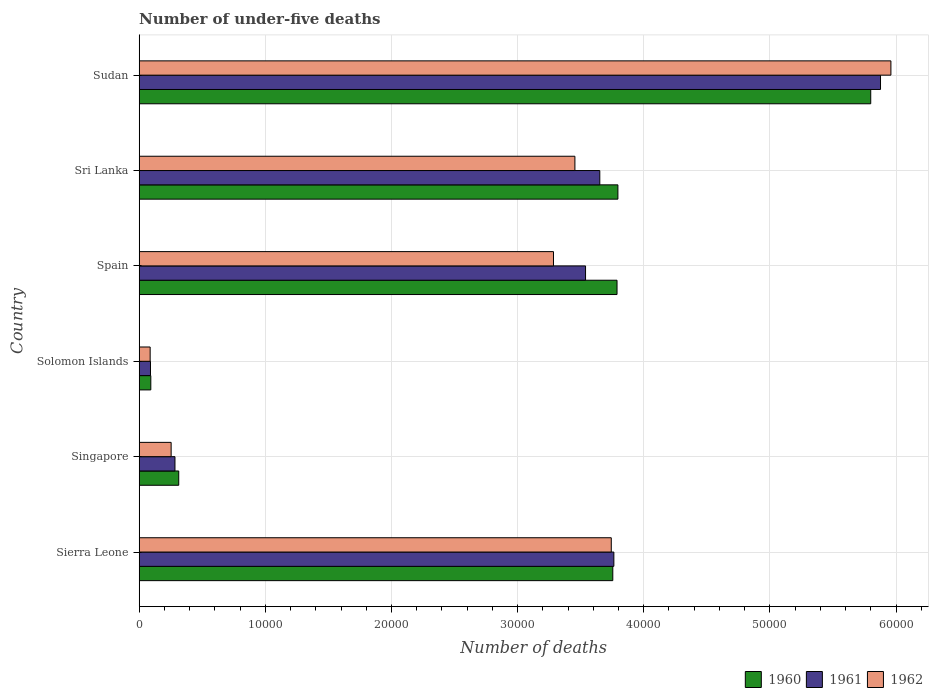How many different coloured bars are there?
Offer a very short reply. 3. How many groups of bars are there?
Keep it short and to the point. 6. Are the number of bars per tick equal to the number of legend labels?
Provide a succinct answer. Yes. How many bars are there on the 2nd tick from the top?
Provide a succinct answer. 3. What is the label of the 6th group of bars from the top?
Make the answer very short. Sierra Leone. What is the number of under-five deaths in 1960 in Sudan?
Provide a short and direct response. 5.80e+04. Across all countries, what is the maximum number of under-five deaths in 1961?
Offer a terse response. 5.88e+04. Across all countries, what is the minimum number of under-five deaths in 1962?
Ensure brevity in your answer.  872. In which country was the number of under-five deaths in 1961 maximum?
Offer a terse response. Sudan. In which country was the number of under-five deaths in 1961 minimum?
Make the answer very short. Solomon Islands. What is the total number of under-five deaths in 1960 in the graph?
Give a very brief answer. 1.75e+05. What is the difference between the number of under-five deaths in 1961 in Spain and that in Sri Lanka?
Your answer should be compact. -1130. What is the difference between the number of under-five deaths in 1962 in Sierra Leone and the number of under-five deaths in 1960 in Spain?
Give a very brief answer. -456. What is the average number of under-five deaths in 1961 per country?
Offer a terse response. 2.87e+04. What is the difference between the number of under-five deaths in 1962 and number of under-five deaths in 1961 in Singapore?
Offer a terse response. -304. In how many countries, is the number of under-five deaths in 1960 greater than 18000 ?
Your response must be concise. 4. What is the ratio of the number of under-five deaths in 1961 in Sierra Leone to that in Solomon Islands?
Offer a terse response. 41.95. Is the number of under-five deaths in 1961 in Singapore less than that in Sri Lanka?
Provide a succinct answer. Yes. Is the difference between the number of under-five deaths in 1962 in Spain and Sri Lanka greater than the difference between the number of under-five deaths in 1961 in Spain and Sri Lanka?
Keep it short and to the point. No. What is the difference between the highest and the second highest number of under-five deaths in 1961?
Your response must be concise. 2.11e+04. What is the difference between the highest and the lowest number of under-five deaths in 1961?
Make the answer very short. 5.79e+04. What does the 1st bar from the top in Solomon Islands represents?
Your answer should be very brief. 1962. What does the 2nd bar from the bottom in Sierra Leone represents?
Your answer should be very brief. 1961. Is it the case that in every country, the sum of the number of under-five deaths in 1962 and number of under-five deaths in 1961 is greater than the number of under-five deaths in 1960?
Offer a terse response. Yes. How many countries are there in the graph?
Offer a very short reply. 6. What is the difference between two consecutive major ticks on the X-axis?
Give a very brief answer. 10000. Where does the legend appear in the graph?
Offer a terse response. Bottom right. What is the title of the graph?
Give a very brief answer. Number of under-five deaths. What is the label or title of the X-axis?
Offer a very short reply. Number of deaths. What is the Number of deaths of 1960 in Sierra Leone?
Offer a very short reply. 3.75e+04. What is the Number of deaths in 1961 in Sierra Leone?
Ensure brevity in your answer.  3.76e+04. What is the Number of deaths in 1962 in Sierra Leone?
Offer a very short reply. 3.74e+04. What is the Number of deaths in 1960 in Singapore?
Your answer should be very brief. 3137. What is the Number of deaths in 1961 in Singapore?
Give a very brief answer. 2839. What is the Number of deaths in 1962 in Singapore?
Provide a succinct answer. 2535. What is the Number of deaths in 1960 in Solomon Islands?
Provide a short and direct response. 923. What is the Number of deaths in 1961 in Solomon Islands?
Make the answer very short. 897. What is the Number of deaths in 1962 in Solomon Islands?
Offer a terse response. 872. What is the Number of deaths in 1960 in Spain?
Provide a succinct answer. 3.79e+04. What is the Number of deaths of 1961 in Spain?
Give a very brief answer. 3.54e+04. What is the Number of deaths in 1962 in Spain?
Provide a succinct answer. 3.28e+04. What is the Number of deaths in 1960 in Sri Lanka?
Your response must be concise. 3.80e+04. What is the Number of deaths of 1961 in Sri Lanka?
Your response must be concise. 3.65e+04. What is the Number of deaths in 1962 in Sri Lanka?
Your answer should be very brief. 3.45e+04. What is the Number of deaths of 1960 in Sudan?
Provide a short and direct response. 5.80e+04. What is the Number of deaths of 1961 in Sudan?
Ensure brevity in your answer.  5.88e+04. What is the Number of deaths in 1962 in Sudan?
Provide a succinct answer. 5.96e+04. Across all countries, what is the maximum Number of deaths in 1960?
Offer a terse response. 5.80e+04. Across all countries, what is the maximum Number of deaths in 1961?
Your answer should be very brief. 5.88e+04. Across all countries, what is the maximum Number of deaths in 1962?
Keep it short and to the point. 5.96e+04. Across all countries, what is the minimum Number of deaths in 1960?
Offer a terse response. 923. Across all countries, what is the minimum Number of deaths of 1961?
Offer a very short reply. 897. Across all countries, what is the minimum Number of deaths in 1962?
Your response must be concise. 872. What is the total Number of deaths in 1960 in the graph?
Offer a terse response. 1.75e+05. What is the total Number of deaths in 1961 in the graph?
Provide a succinct answer. 1.72e+05. What is the total Number of deaths of 1962 in the graph?
Your response must be concise. 1.68e+05. What is the difference between the Number of deaths of 1960 in Sierra Leone and that in Singapore?
Your answer should be compact. 3.44e+04. What is the difference between the Number of deaths in 1961 in Sierra Leone and that in Singapore?
Provide a short and direct response. 3.48e+04. What is the difference between the Number of deaths in 1962 in Sierra Leone and that in Singapore?
Offer a very short reply. 3.49e+04. What is the difference between the Number of deaths of 1960 in Sierra Leone and that in Solomon Islands?
Your response must be concise. 3.66e+04. What is the difference between the Number of deaths in 1961 in Sierra Leone and that in Solomon Islands?
Your answer should be compact. 3.67e+04. What is the difference between the Number of deaths in 1962 in Sierra Leone and that in Solomon Islands?
Ensure brevity in your answer.  3.66e+04. What is the difference between the Number of deaths in 1960 in Sierra Leone and that in Spain?
Offer a very short reply. -335. What is the difference between the Number of deaths in 1961 in Sierra Leone and that in Spain?
Provide a succinct answer. 2245. What is the difference between the Number of deaths of 1962 in Sierra Leone and that in Spain?
Your response must be concise. 4581. What is the difference between the Number of deaths of 1960 in Sierra Leone and that in Sri Lanka?
Offer a very short reply. -405. What is the difference between the Number of deaths of 1961 in Sierra Leone and that in Sri Lanka?
Give a very brief answer. 1115. What is the difference between the Number of deaths of 1962 in Sierra Leone and that in Sri Lanka?
Give a very brief answer. 2883. What is the difference between the Number of deaths in 1960 in Sierra Leone and that in Sudan?
Your response must be concise. -2.04e+04. What is the difference between the Number of deaths in 1961 in Sierra Leone and that in Sudan?
Offer a very short reply. -2.11e+04. What is the difference between the Number of deaths in 1962 in Sierra Leone and that in Sudan?
Your answer should be compact. -2.22e+04. What is the difference between the Number of deaths in 1960 in Singapore and that in Solomon Islands?
Provide a succinct answer. 2214. What is the difference between the Number of deaths in 1961 in Singapore and that in Solomon Islands?
Offer a very short reply. 1942. What is the difference between the Number of deaths of 1962 in Singapore and that in Solomon Islands?
Ensure brevity in your answer.  1663. What is the difference between the Number of deaths of 1960 in Singapore and that in Spain?
Give a very brief answer. -3.47e+04. What is the difference between the Number of deaths in 1961 in Singapore and that in Spain?
Provide a succinct answer. -3.25e+04. What is the difference between the Number of deaths of 1962 in Singapore and that in Spain?
Your answer should be very brief. -3.03e+04. What is the difference between the Number of deaths in 1960 in Singapore and that in Sri Lanka?
Your answer should be very brief. -3.48e+04. What is the difference between the Number of deaths in 1961 in Singapore and that in Sri Lanka?
Give a very brief answer. -3.37e+04. What is the difference between the Number of deaths in 1962 in Singapore and that in Sri Lanka?
Offer a very short reply. -3.20e+04. What is the difference between the Number of deaths of 1960 in Singapore and that in Sudan?
Offer a terse response. -5.49e+04. What is the difference between the Number of deaths in 1961 in Singapore and that in Sudan?
Make the answer very short. -5.59e+04. What is the difference between the Number of deaths in 1962 in Singapore and that in Sudan?
Keep it short and to the point. -5.71e+04. What is the difference between the Number of deaths of 1960 in Solomon Islands and that in Spain?
Give a very brief answer. -3.70e+04. What is the difference between the Number of deaths of 1961 in Solomon Islands and that in Spain?
Your response must be concise. -3.45e+04. What is the difference between the Number of deaths in 1962 in Solomon Islands and that in Spain?
Provide a short and direct response. -3.20e+04. What is the difference between the Number of deaths in 1960 in Solomon Islands and that in Sri Lanka?
Your answer should be compact. -3.70e+04. What is the difference between the Number of deaths in 1961 in Solomon Islands and that in Sri Lanka?
Offer a terse response. -3.56e+04. What is the difference between the Number of deaths of 1962 in Solomon Islands and that in Sri Lanka?
Ensure brevity in your answer.  -3.37e+04. What is the difference between the Number of deaths of 1960 in Solomon Islands and that in Sudan?
Make the answer very short. -5.71e+04. What is the difference between the Number of deaths in 1961 in Solomon Islands and that in Sudan?
Offer a very short reply. -5.79e+04. What is the difference between the Number of deaths in 1962 in Solomon Islands and that in Sudan?
Your answer should be compact. -5.87e+04. What is the difference between the Number of deaths of 1960 in Spain and that in Sri Lanka?
Offer a terse response. -70. What is the difference between the Number of deaths in 1961 in Spain and that in Sri Lanka?
Provide a succinct answer. -1130. What is the difference between the Number of deaths of 1962 in Spain and that in Sri Lanka?
Offer a terse response. -1698. What is the difference between the Number of deaths in 1960 in Spain and that in Sudan?
Your answer should be compact. -2.01e+04. What is the difference between the Number of deaths in 1961 in Spain and that in Sudan?
Provide a short and direct response. -2.34e+04. What is the difference between the Number of deaths of 1962 in Spain and that in Sudan?
Offer a terse response. -2.67e+04. What is the difference between the Number of deaths of 1960 in Sri Lanka and that in Sudan?
Your answer should be very brief. -2.00e+04. What is the difference between the Number of deaths of 1961 in Sri Lanka and that in Sudan?
Offer a terse response. -2.23e+04. What is the difference between the Number of deaths in 1962 in Sri Lanka and that in Sudan?
Your response must be concise. -2.50e+04. What is the difference between the Number of deaths in 1960 in Sierra Leone and the Number of deaths in 1961 in Singapore?
Your answer should be compact. 3.47e+04. What is the difference between the Number of deaths in 1960 in Sierra Leone and the Number of deaths in 1962 in Singapore?
Your answer should be very brief. 3.50e+04. What is the difference between the Number of deaths of 1961 in Sierra Leone and the Number of deaths of 1962 in Singapore?
Ensure brevity in your answer.  3.51e+04. What is the difference between the Number of deaths of 1960 in Sierra Leone and the Number of deaths of 1961 in Solomon Islands?
Provide a short and direct response. 3.66e+04. What is the difference between the Number of deaths in 1960 in Sierra Leone and the Number of deaths in 1962 in Solomon Islands?
Keep it short and to the point. 3.67e+04. What is the difference between the Number of deaths in 1961 in Sierra Leone and the Number of deaths in 1962 in Solomon Islands?
Offer a terse response. 3.68e+04. What is the difference between the Number of deaths in 1960 in Sierra Leone and the Number of deaths in 1961 in Spain?
Provide a short and direct response. 2161. What is the difference between the Number of deaths in 1960 in Sierra Leone and the Number of deaths in 1962 in Spain?
Ensure brevity in your answer.  4702. What is the difference between the Number of deaths in 1961 in Sierra Leone and the Number of deaths in 1962 in Spain?
Offer a terse response. 4786. What is the difference between the Number of deaths of 1960 in Sierra Leone and the Number of deaths of 1961 in Sri Lanka?
Your answer should be compact. 1031. What is the difference between the Number of deaths in 1960 in Sierra Leone and the Number of deaths in 1962 in Sri Lanka?
Offer a very short reply. 3004. What is the difference between the Number of deaths of 1961 in Sierra Leone and the Number of deaths of 1962 in Sri Lanka?
Give a very brief answer. 3088. What is the difference between the Number of deaths in 1960 in Sierra Leone and the Number of deaths in 1961 in Sudan?
Give a very brief answer. -2.12e+04. What is the difference between the Number of deaths in 1960 in Sierra Leone and the Number of deaths in 1962 in Sudan?
Give a very brief answer. -2.20e+04. What is the difference between the Number of deaths of 1961 in Sierra Leone and the Number of deaths of 1962 in Sudan?
Provide a succinct answer. -2.20e+04. What is the difference between the Number of deaths in 1960 in Singapore and the Number of deaths in 1961 in Solomon Islands?
Your response must be concise. 2240. What is the difference between the Number of deaths of 1960 in Singapore and the Number of deaths of 1962 in Solomon Islands?
Provide a succinct answer. 2265. What is the difference between the Number of deaths of 1961 in Singapore and the Number of deaths of 1962 in Solomon Islands?
Ensure brevity in your answer.  1967. What is the difference between the Number of deaths in 1960 in Singapore and the Number of deaths in 1961 in Spain?
Keep it short and to the point. -3.22e+04. What is the difference between the Number of deaths in 1960 in Singapore and the Number of deaths in 1962 in Spain?
Offer a very short reply. -2.97e+04. What is the difference between the Number of deaths of 1961 in Singapore and the Number of deaths of 1962 in Spain?
Your answer should be very brief. -3.00e+04. What is the difference between the Number of deaths of 1960 in Singapore and the Number of deaths of 1961 in Sri Lanka?
Your answer should be compact. -3.34e+04. What is the difference between the Number of deaths in 1960 in Singapore and the Number of deaths in 1962 in Sri Lanka?
Offer a very short reply. -3.14e+04. What is the difference between the Number of deaths in 1961 in Singapore and the Number of deaths in 1962 in Sri Lanka?
Your answer should be very brief. -3.17e+04. What is the difference between the Number of deaths of 1960 in Singapore and the Number of deaths of 1961 in Sudan?
Offer a very short reply. -5.56e+04. What is the difference between the Number of deaths in 1960 in Singapore and the Number of deaths in 1962 in Sudan?
Offer a very short reply. -5.65e+04. What is the difference between the Number of deaths of 1961 in Singapore and the Number of deaths of 1962 in Sudan?
Your answer should be very brief. -5.68e+04. What is the difference between the Number of deaths of 1960 in Solomon Islands and the Number of deaths of 1961 in Spain?
Offer a terse response. -3.45e+04. What is the difference between the Number of deaths of 1960 in Solomon Islands and the Number of deaths of 1962 in Spain?
Give a very brief answer. -3.19e+04. What is the difference between the Number of deaths in 1961 in Solomon Islands and the Number of deaths in 1962 in Spain?
Provide a short and direct response. -3.19e+04. What is the difference between the Number of deaths in 1960 in Solomon Islands and the Number of deaths in 1961 in Sri Lanka?
Ensure brevity in your answer.  -3.56e+04. What is the difference between the Number of deaths in 1960 in Solomon Islands and the Number of deaths in 1962 in Sri Lanka?
Ensure brevity in your answer.  -3.36e+04. What is the difference between the Number of deaths of 1961 in Solomon Islands and the Number of deaths of 1962 in Sri Lanka?
Provide a short and direct response. -3.36e+04. What is the difference between the Number of deaths of 1960 in Solomon Islands and the Number of deaths of 1961 in Sudan?
Your answer should be compact. -5.78e+04. What is the difference between the Number of deaths of 1960 in Solomon Islands and the Number of deaths of 1962 in Sudan?
Provide a short and direct response. -5.87e+04. What is the difference between the Number of deaths in 1961 in Solomon Islands and the Number of deaths in 1962 in Sudan?
Offer a terse response. -5.87e+04. What is the difference between the Number of deaths in 1960 in Spain and the Number of deaths in 1961 in Sri Lanka?
Ensure brevity in your answer.  1366. What is the difference between the Number of deaths of 1960 in Spain and the Number of deaths of 1962 in Sri Lanka?
Offer a terse response. 3339. What is the difference between the Number of deaths in 1961 in Spain and the Number of deaths in 1962 in Sri Lanka?
Offer a terse response. 843. What is the difference between the Number of deaths in 1960 in Spain and the Number of deaths in 1961 in Sudan?
Offer a terse response. -2.09e+04. What is the difference between the Number of deaths in 1960 in Spain and the Number of deaths in 1962 in Sudan?
Give a very brief answer. -2.17e+04. What is the difference between the Number of deaths in 1961 in Spain and the Number of deaths in 1962 in Sudan?
Offer a terse response. -2.42e+04. What is the difference between the Number of deaths in 1960 in Sri Lanka and the Number of deaths in 1961 in Sudan?
Ensure brevity in your answer.  -2.08e+04. What is the difference between the Number of deaths in 1960 in Sri Lanka and the Number of deaths in 1962 in Sudan?
Provide a succinct answer. -2.16e+04. What is the difference between the Number of deaths of 1961 in Sri Lanka and the Number of deaths of 1962 in Sudan?
Provide a short and direct response. -2.31e+04. What is the average Number of deaths of 1960 per country?
Offer a very short reply. 2.92e+04. What is the average Number of deaths in 1961 per country?
Make the answer very short. 2.87e+04. What is the average Number of deaths of 1962 per country?
Offer a very short reply. 2.80e+04. What is the difference between the Number of deaths in 1960 and Number of deaths in 1961 in Sierra Leone?
Provide a short and direct response. -84. What is the difference between the Number of deaths in 1960 and Number of deaths in 1962 in Sierra Leone?
Keep it short and to the point. 121. What is the difference between the Number of deaths of 1961 and Number of deaths of 1962 in Sierra Leone?
Provide a succinct answer. 205. What is the difference between the Number of deaths of 1960 and Number of deaths of 1961 in Singapore?
Ensure brevity in your answer.  298. What is the difference between the Number of deaths in 1960 and Number of deaths in 1962 in Singapore?
Offer a very short reply. 602. What is the difference between the Number of deaths of 1961 and Number of deaths of 1962 in Singapore?
Your response must be concise. 304. What is the difference between the Number of deaths in 1960 and Number of deaths in 1962 in Solomon Islands?
Offer a very short reply. 51. What is the difference between the Number of deaths of 1961 and Number of deaths of 1962 in Solomon Islands?
Provide a succinct answer. 25. What is the difference between the Number of deaths of 1960 and Number of deaths of 1961 in Spain?
Provide a succinct answer. 2496. What is the difference between the Number of deaths in 1960 and Number of deaths in 1962 in Spain?
Ensure brevity in your answer.  5037. What is the difference between the Number of deaths of 1961 and Number of deaths of 1962 in Spain?
Offer a very short reply. 2541. What is the difference between the Number of deaths of 1960 and Number of deaths of 1961 in Sri Lanka?
Ensure brevity in your answer.  1436. What is the difference between the Number of deaths in 1960 and Number of deaths in 1962 in Sri Lanka?
Your response must be concise. 3409. What is the difference between the Number of deaths in 1961 and Number of deaths in 1962 in Sri Lanka?
Your answer should be very brief. 1973. What is the difference between the Number of deaths in 1960 and Number of deaths in 1961 in Sudan?
Your answer should be compact. -775. What is the difference between the Number of deaths of 1960 and Number of deaths of 1962 in Sudan?
Your response must be concise. -1599. What is the difference between the Number of deaths of 1961 and Number of deaths of 1962 in Sudan?
Ensure brevity in your answer.  -824. What is the ratio of the Number of deaths in 1960 in Sierra Leone to that in Singapore?
Make the answer very short. 11.97. What is the ratio of the Number of deaths of 1961 in Sierra Leone to that in Singapore?
Your response must be concise. 13.26. What is the ratio of the Number of deaths in 1962 in Sierra Leone to that in Singapore?
Offer a terse response. 14.76. What is the ratio of the Number of deaths of 1960 in Sierra Leone to that in Solomon Islands?
Offer a terse response. 40.68. What is the ratio of the Number of deaths in 1961 in Sierra Leone to that in Solomon Islands?
Keep it short and to the point. 41.95. What is the ratio of the Number of deaths of 1962 in Sierra Leone to that in Solomon Islands?
Provide a short and direct response. 42.92. What is the ratio of the Number of deaths in 1961 in Sierra Leone to that in Spain?
Give a very brief answer. 1.06. What is the ratio of the Number of deaths in 1962 in Sierra Leone to that in Spain?
Make the answer very short. 1.14. What is the ratio of the Number of deaths in 1960 in Sierra Leone to that in Sri Lanka?
Offer a very short reply. 0.99. What is the ratio of the Number of deaths of 1961 in Sierra Leone to that in Sri Lanka?
Give a very brief answer. 1.03. What is the ratio of the Number of deaths of 1962 in Sierra Leone to that in Sri Lanka?
Your response must be concise. 1.08. What is the ratio of the Number of deaths in 1960 in Sierra Leone to that in Sudan?
Offer a very short reply. 0.65. What is the ratio of the Number of deaths in 1961 in Sierra Leone to that in Sudan?
Make the answer very short. 0.64. What is the ratio of the Number of deaths of 1962 in Sierra Leone to that in Sudan?
Your answer should be very brief. 0.63. What is the ratio of the Number of deaths of 1960 in Singapore to that in Solomon Islands?
Offer a very short reply. 3.4. What is the ratio of the Number of deaths in 1961 in Singapore to that in Solomon Islands?
Keep it short and to the point. 3.17. What is the ratio of the Number of deaths in 1962 in Singapore to that in Solomon Islands?
Offer a very short reply. 2.91. What is the ratio of the Number of deaths in 1960 in Singapore to that in Spain?
Keep it short and to the point. 0.08. What is the ratio of the Number of deaths of 1961 in Singapore to that in Spain?
Make the answer very short. 0.08. What is the ratio of the Number of deaths of 1962 in Singapore to that in Spain?
Offer a very short reply. 0.08. What is the ratio of the Number of deaths in 1960 in Singapore to that in Sri Lanka?
Your answer should be compact. 0.08. What is the ratio of the Number of deaths in 1961 in Singapore to that in Sri Lanka?
Ensure brevity in your answer.  0.08. What is the ratio of the Number of deaths of 1962 in Singapore to that in Sri Lanka?
Ensure brevity in your answer.  0.07. What is the ratio of the Number of deaths in 1960 in Singapore to that in Sudan?
Provide a short and direct response. 0.05. What is the ratio of the Number of deaths of 1961 in Singapore to that in Sudan?
Make the answer very short. 0.05. What is the ratio of the Number of deaths in 1962 in Singapore to that in Sudan?
Make the answer very short. 0.04. What is the ratio of the Number of deaths in 1960 in Solomon Islands to that in Spain?
Offer a terse response. 0.02. What is the ratio of the Number of deaths in 1961 in Solomon Islands to that in Spain?
Your answer should be compact. 0.03. What is the ratio of the Number of deaths of 1962 in Solomon Islands to that in Spain?
Offer a terse response. 0.03. What is the ratio of the Number of deaths of 1960 in Solomon Islands to that in Sri Lanka?
Make the answer very short. 0.02. What is the ratio of the Number of deaths in 1961 in Solomon Islands to that in Sri Lanka?
Provide a short and direct response. 0.02. What is the ratio of the Number of deaths in 1962 in Solomon Islands to that in Sri Lanka?
Your response must be concise. 0.03. What is the ratio of the Number of deaths in 1960 in Solomon Islands to that in Sudan?
Offer a very short reply. 0.02. What is the ratio of the Number of deaths in 1961 in Solomon Islands to that in Sudan?
Your response must be concise. 0.02. What is the ratio of the Number of deaths in 1962 in Solomon Islands to that in Sudan?
Provide a succinct answer. 0.01. What is the ratio of the Number of deaths in 1960 in Spain to that in Sri Lanka?
Your response must be concise. 1. What is the ratio of the Number of deaths of 1961 in Spain to that in Sri Lanka?
Keep it short and to the point. 0.97. What is the ratio of the Number of deaths of 1962 in Spain to that in Sri Lanka?
Your answer should be very brief. 0.95. What is the ratio of the Number of deaths of 1960 in Spain to that in Sudan?
Ensure brevity in your answer.  0.65. What is the ratio of the Number of deaths of 1961 in Spain to that in Sudan?
Offer a terse response. 0.6. What is the ratio of the Number of deaths of 1962 in Spain to that in Sudan?
Your answer should be compact. 0.55. What is the ratio of the Number of deaths in 1960 in Sri Lanka to that in Sudan?
Provide a short and direct response. 0.65. What is the ratio of the Number of deaths in 1961 in Sri Lanka to that in Sudan?
Offer a terse response. 0.62. What is the ratio of the Number of deaths in 1962 in Sri Lanka to that in Sudan?
Keep it short and to the point. 0.58. What is the difference between the highest and the second highest Number of deaths in 1960?
Your answer should be very brief. 2.00e+04. What is the difference between the highest and the second highest Number of deaths in 1961?
Keep it short and to the point. 2.11e+04. What is the difference between the highest and the second highest Number of deaths of 1962?
Give a very brief answer. 2.22e+04. What is the difference between the highest and the lowest Number of deaths of 1960?
Keep it short and to the point. 5.71e+04. What is the difference between the highest and the lowest Number of deaths of 1961?
Provide a succinct answer. 5.79e+04. What is the difference between the highest and the lowest Number of deaths in 1962?
Offer a very short reply. 5.87e+04. 